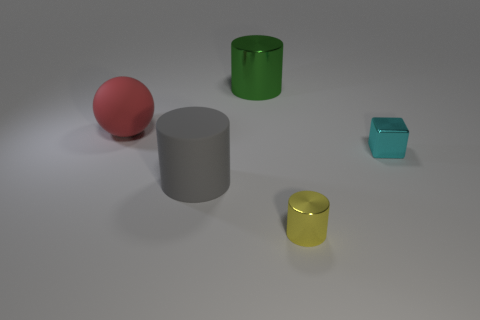What number of gray things are metallic objects or tiny objects?
Offer a terse response. 0. Is there a red ball behind the shiny cylinder that is behind the large cylinder left of the green object?
Offer a very short reply. No. Is there any other thing that has the same size as the gray rubber thing?
Give a very brief answer. Yes. Is the small metal cylinder the same color as the big rubber cylinder?
Offer a very short reply. No. What color is the metallic cylinder that is behind the metallic thing in front of the cyan metal object?
Provide a short and direct response. Green. What number of small things are either green metallic things or yellow metallic things?
Provide a succinct answer. 1. There is a object that is both in front of the red matte ball and on the left side of the tiny cylinder; what color is it?
Your answer should be compact. Gray. Are the block and the large gray object made of the same material?
Your answer should be compact. No. There is a large red object; what shape is it?
Make the answer very short. Sphere. There is a big matte object that is behind the small object that is right of the yellow metallic thing; what number of big gray rubber cylinders are to the right of it?
Make the answer very short. 1. 